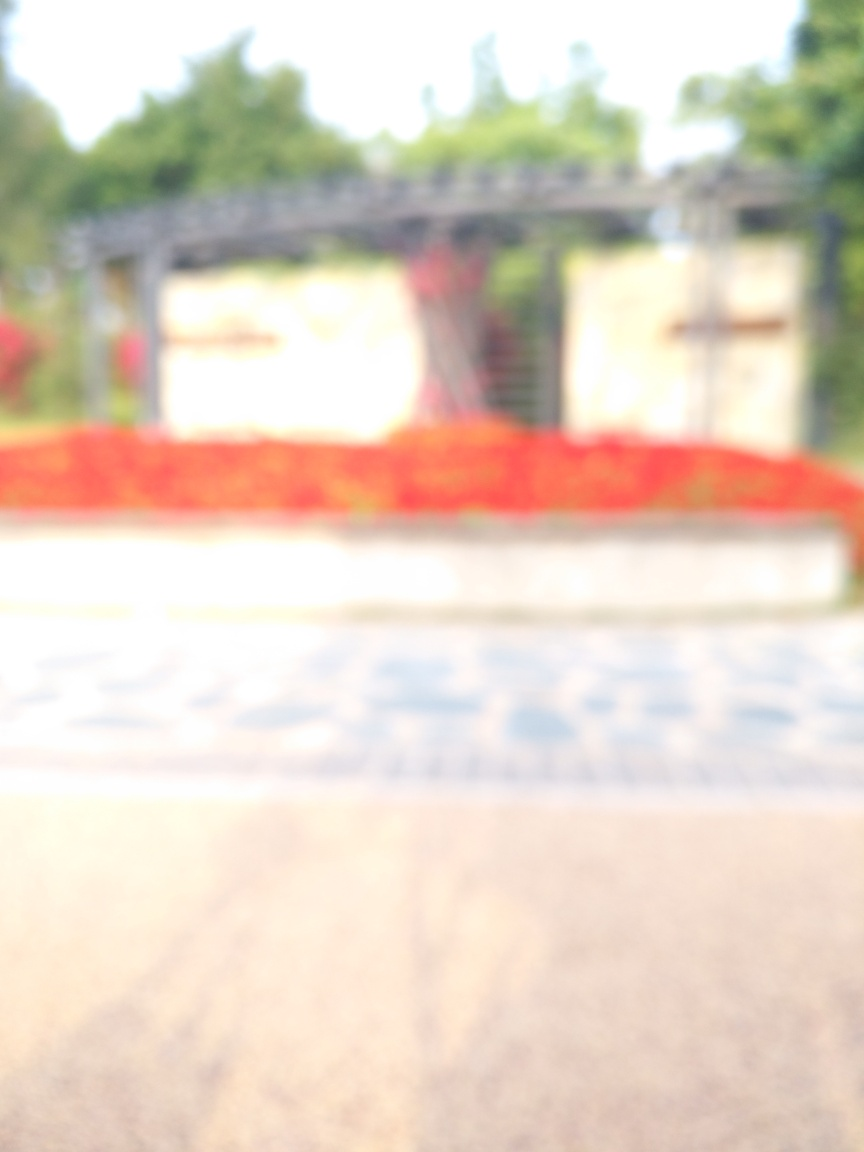What could be the possible location or setting of this image based on the colors and structures perceived? The warm tones and the impression of an overhead structure might indicate a garden or park setting, potentially a place designed for relaxation or as a point of interest where the red elements could be seasonal decorations or flowering plants. What time of day does the lighting in the image suggest? The lighting appears to be natural and diffused, with no hard shadows visible. This could suggest either an overcast day or a time when the sun is at a lower angle, such as early morning or late afternoon. 